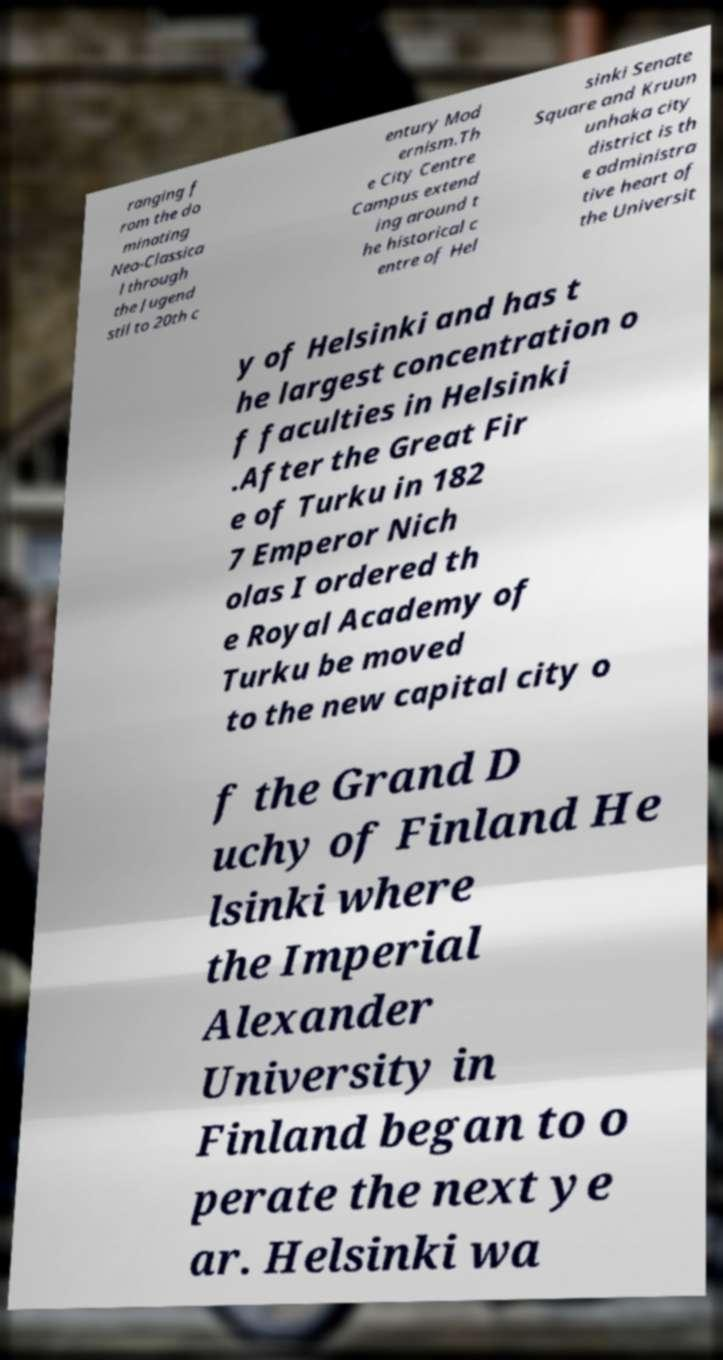There's text embedded in this image that I need extracted. Can you transcribe it verbatim? ranging f rom the do minating Neo-Classica l through the Jugend stil to 20th c entury Mod ernism.Th e City Centre Campus extend ing around t he historical c entre of Hel sinki Senate Square and Kruun unhaka city district is th e administra tive heart of the Universit y of Helsinki and has t he largest concentration o f faculties in Helsinki .After the Great Fir e of Turku in 182 7 Emperor Nich olas I ordered th e Royal Academy of Turku be moved to the new capital city o f the Grand D uchy of Finland He lsinki where the Imperial Alexander University in Finland began to o perate the next ye ar. Helsinki wa 